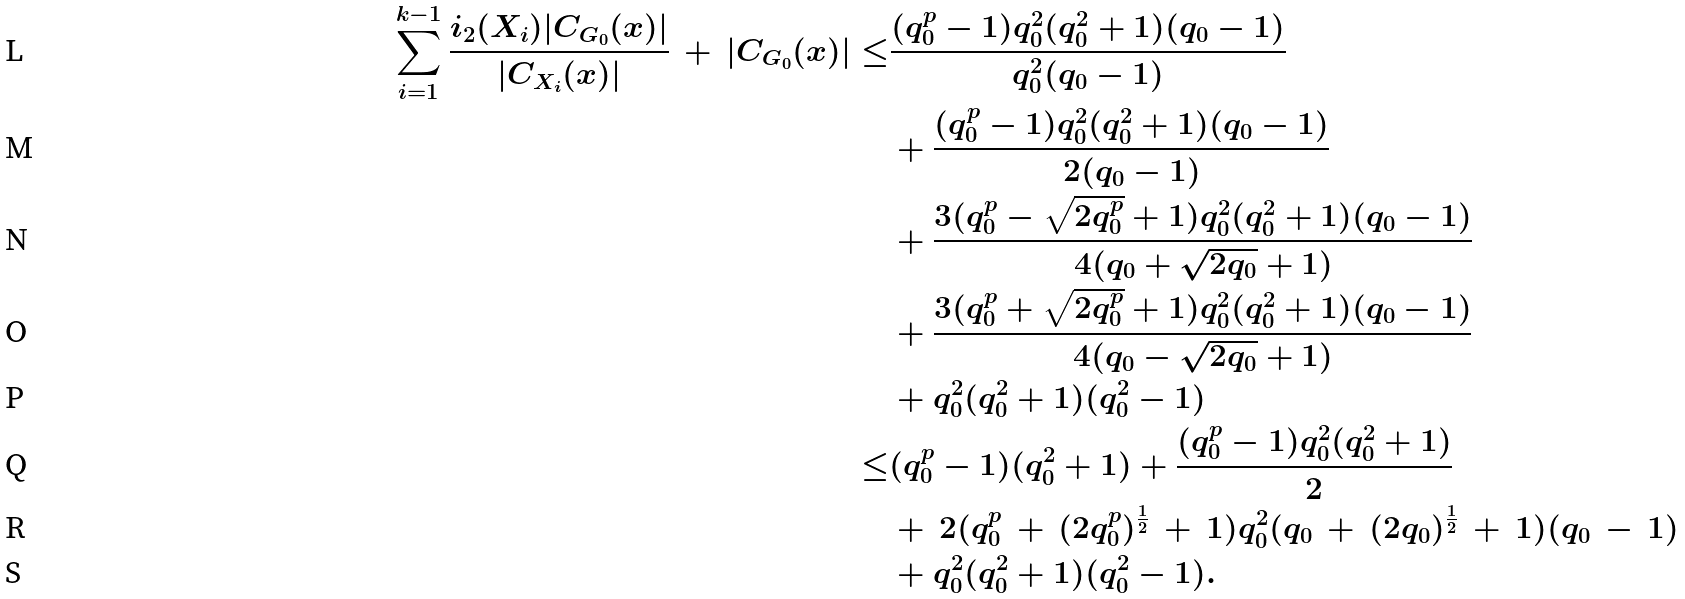Convert formula to latex. <formula><loc_0><loc_0><loc_500><loc_500>\sum _ { i = 1 } ^ { k - 1 } \frac { i _ { 2 } ( X _ { i } ) | C _ { G _ { 0 } } ( x ) | } { | C _ { X _ { i } } ( x ) | } \, + \, | C _ { G _ { 0 } } ( x ) | \leq & \frac { ( q _ { 0 } ^ { p } - 1 ) q _ { 0 } ^ { 2 } ( q _ { 0 } ^ { 2 } + 1 ) ( q _ { 0 } - 1 ) } { q _ { 0 } ^ { 2 } ( q _ { 0 } - 1 ) } \\ & + \frac { ( q _ { 0 } ^ { p } - 1 ) q _ { 0 } ^ { 2 } ( q _ { 0 } ^ { 2 } + 1 ) ( q _ { 0 } - 1 ) } { 2 ( q _ { 0 } - 1 ) } \\ & + \frac { 3 ( q _ { 0 } ^ { p } - \sqrt { 2 q _ { 0 } ^ { p } } + 1 ) q _ { 0 } ^ { 2 } ( q _ { 0 } ^ { 2 } + 1 ) ( q _ { 0 } - 1 ) } { 4 ( q _ { 0 } + \sqrt { 2 q _ { 0 } } + 1 ) } \\ & + \frac { 3 ( q _ { 0 } ^ { p } + \sqrt { 2 q _ { 0 } ^ { p } } + 1 ) q _ { 0 } ^ { 2 } ( q _ { 0 } ^ { 2 } + 1 ) ( q _ { 0 } - 1 ) } { 4 ( q _ { 0 } - \sqrt { 2 q _ { 0 } } + 1 ) } \\ & + q _ { 0 } ^ { 2 } ( q _ { 0 } ^ { 2 } + 1 ) ( q _ { 0 } ^ { 2 } - 1 ) \\ \leq & ( q _ { 0 } ^ { p } - 1 ) ( q _ { 0 } ^ { 2 } + 1 ) + \frac { ( q _ { 0 } ^ { p } - 1 ) q _ { 0 } ^ { 2 } ( q _ { 0 } ^ { 2 } + 1 ) } { 2 } \\ & + \, 2 ( q _ { 0 } ^ { p } \, + \, ( 2 q _ { 0 } ^ { p } ) ^ { \frac { 1 } { 2 } } \, + \, 1 ) q _ { 0 } ^ { 2 } ( q _ { 0 } \, + \, ( 2 q _ { 0 } ) ^ { \frac { 1 } { 2 } } \, + \, 1 ) ( q _ { 0 } \, - \, 1 ) \\ & + q _ { 0 } ^ { 2 } ( q _ { 0 } ^ { 2 } + 1 ) ( q _ { 0 } ^ { 2 } - 1 ) .</formula> 